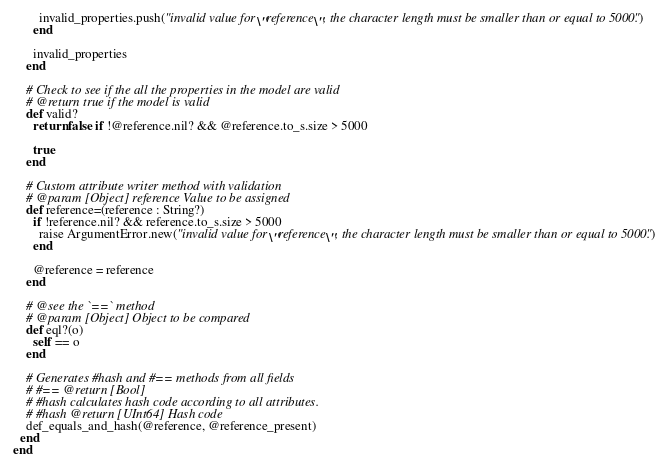<code> <loc_0><loc_0><loc_500><loc_500><_Crystal_>        invalid_properties.push("invalid value for \"reference\", the character length must be smaller than or equal to 5000.")
      end

      invalid_properties
    end

    # Check to see if the all the properties in the model are valid
    # @return true if the model is valid
    def valid?
      return false if !@reference.nil? && @reference.to_s.size > 5000

      true
    end

    # Custom attribute writer method with validation
    # @param [Object] reference Value to be assigned
    def reference=(reference : String?)
      if !reference.nil? && reference.to_s.size > 5000
        raise ArgumentError.new("invalid value for \"reference\", the character length must be smaller than or equal to 5000.")
      end

      @reference = reference
    end

    # @see the `==` method
    # @param [Object] Object to be compared
    def eql?(o)
      self == o
    end

    # Generates #hash and #== methods from all fields
    # #== @return [Bool]
    # #hash calculates hash code according to all attributes.
    # #hash @return [UInt64] Hash code
    def_equals_and_hash(@reference, @reference_present)
  end
end
</code> 